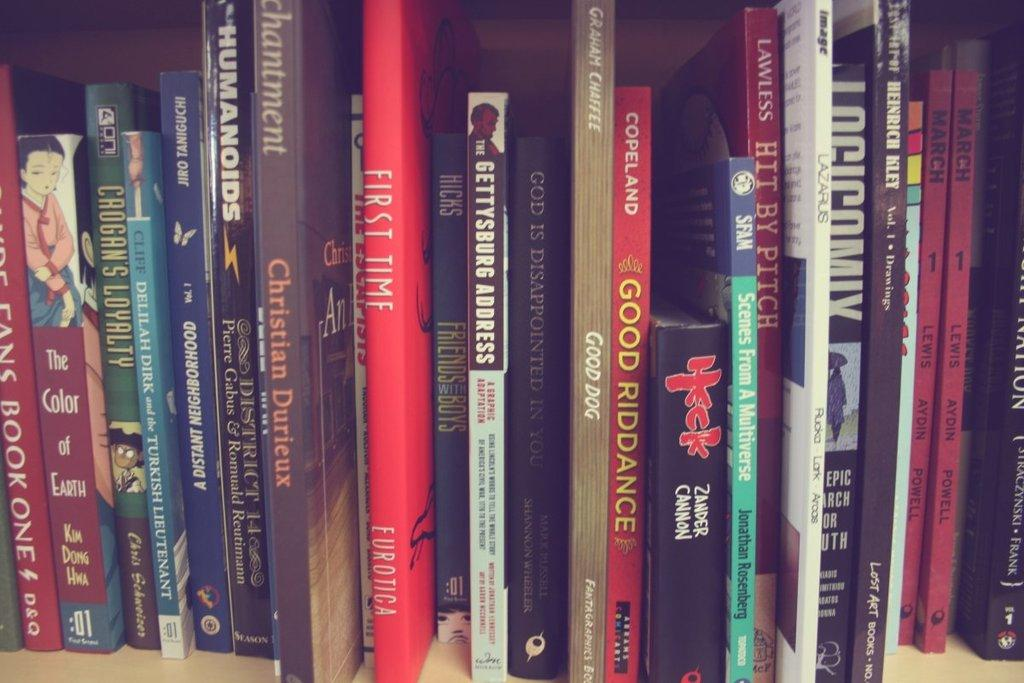Provide a one-sentence caption for the provided image. A red book with the title, "First Time" in on the shelf. 